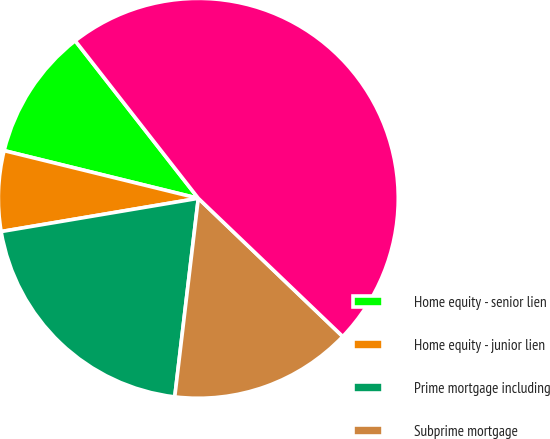Convert chart. <chart><loc_0><loc_0><loc_500><loc_500><pie_chart><fcel>Home equity - senior lien<fcel>Home equity - junior lien<fcel>Prime mortgage including<fcel>Subprime mortgage<fcel>Total modified residential<nl><fcel>10.61%<fcel>6.49%<fcel>20.46%<fcel>14.73%<fcel>47.7%<nl></chart> 